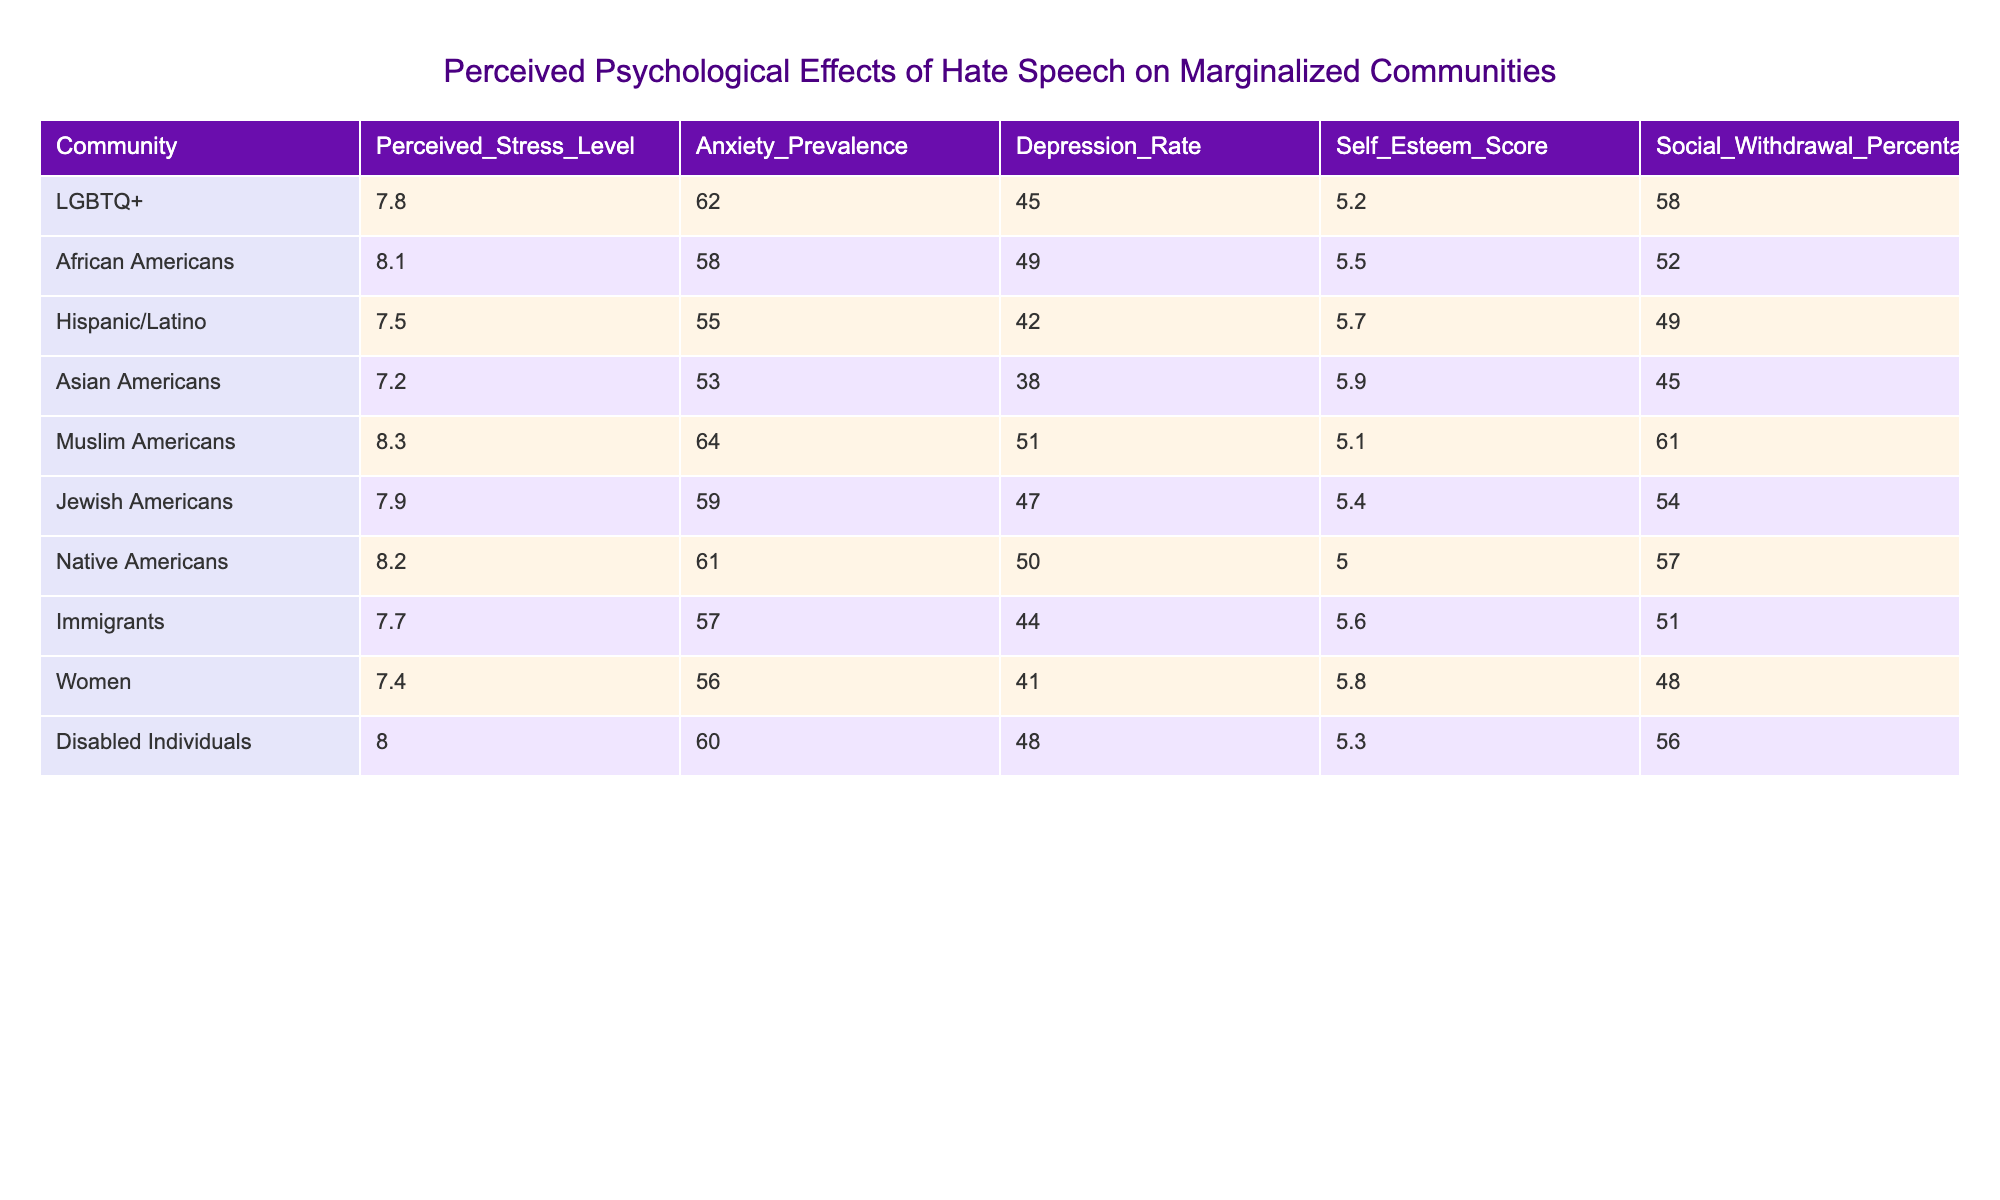What is the perceived stress level of the LGBTQ+ community? The table shows a specific value for the LGBTQ+ community under the "Perceived Stress Level" column, which indicates a level of 7.8.
Answer: 7.8 Which community has the highest anxiety prevalence? By looking at the "Anxiety Prevalence" column, we can see that Muslim Americans have the highest value at 64.
Answer: 64 What is the depression rate for Women? The table provides the depression rate specific to Women, which is listed as 41.
Answer: 41 Which community has the lowest self-esteem score? The "Self Esteem Score" column reveals that Native Americans have the lowest score at 5.0.
Answer: 5.0 What is the average perceived stress level across all communities? To find the average, we sum all perceived stress levels (7.8 + 8.1 + 7.5 + 7.2 + 8.3 + 7.9 + 8.2 + 7.7 + 7.4 + 8.0) = 79.7 and divide by the number of communities, which is 10, giving us an average of 7.97.
Answer: 7.97 Is the anxiety prevalence rate for African Americans higher than that for Hispanic/Latino individuals? Looking at the respective values, African Americans have 58 while Hispanic/Latino individuals have 55. Since 58 is greater than 55, the statement is true.
Answer: Yes What is the difference in depression rates between Muslim Americans and Asian Americans? The depression rate for Muslim Americans is 51, and for Asian Americans, it is 38. The difference can be calculated as 51 - 38 = 13.
Answer: 13 In which community is the social withdrawal percentage highest, and what is that percentage? Comparing the values in the "Social Withdrawal Percentage" column reveals that LGBTQ+ has the highest percentage at 58.
Answer: LGBTQ+, 58 What is the average depression rate for disabled individuals and African Americans? The depression rates for disabled individuals and African Americans are 48 and 49, respectively. The average is calculated as (48 + 49) / 2 = 48.5.
Answer: 48.5 Which community experiences the least social withdrawal, and what is the percentage? By examining the "Social Withdrawal Percentage" column, we can see that Women have the lowest percentage of 48.
Answer: Women, 48 